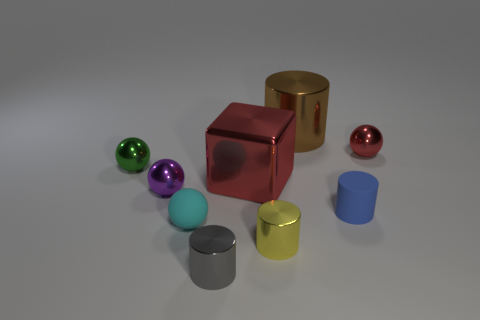What number of objects are either tiny blue rubber cylinders or brown metal things?
Offer a terse response. 2. Are there an equal number of green metal objects that are to the right of the tiny cyan matte object and rubber cylinders?
Your answer should be very brief. No. Are there any cylinders in front of the metallic sphere on the right side of the tiny matte object on the left side of the brown metallic cylinder?
Ensure brevity in your answer.  Yes. What color is the big block that is made of the same material as the yellow cylinder?
Ensure brevity in your answer.  Red. There is a large object behind the large red object; is it the same color as the big shiny cube?
Offer a very short reply. No. How many blocks are either tiny green things or big brown objects?
Offer a terse response. 0. What size is the gray metallic thing that is left of the object behind the red thing to the right of the big brown object?
Your answer should be compact. Small. There is a green thing that is the same size as the rubber cylinder; what shape is it?
Offer a very short reply. Sphere. What is the shape of the yellow metal object?
Provide a short and direct response. Cylinder. Is the small object to the left of the purple sphere made of the same material as the big brown thing?
Keep it short and to the point. Yes. 